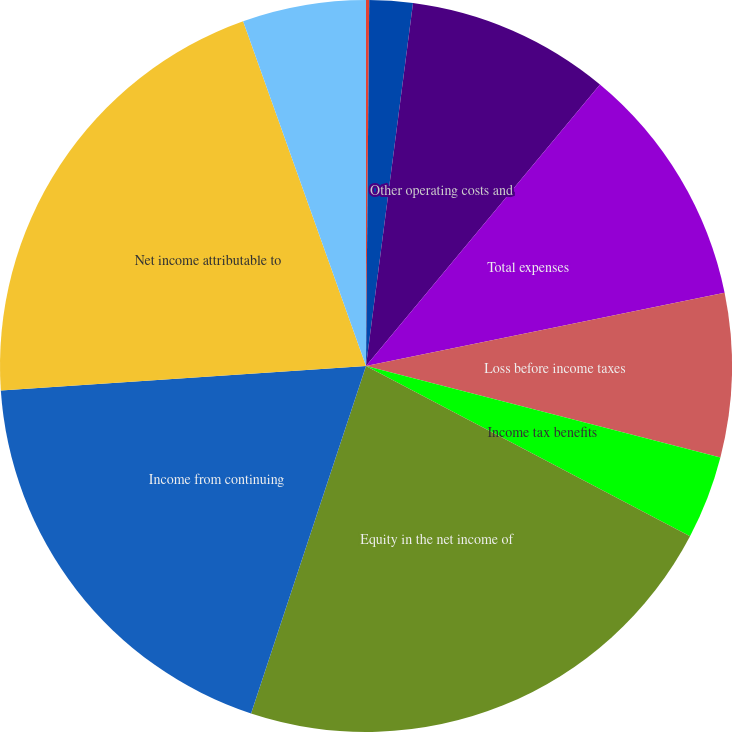<chart> <loc_0><loc_0><loc_500><loc_500><pie_chart><fcel>Net investment income (loss)<fcel>Total revenues<fcel>Other operating costs and<fcel>Total expenses<fcel>Loss before income taxes<fcel>Income tax benefits<fcel>Equity in the net income of<fcel>Income from continuing<fcel>Net income attributable to<fcel>Preferred stock dividends<nl><fcel>0.14%<fcel>1.91%<fcel>8.99%<fcel>10.76%<fcel>7.22%<fcel>3.68%<fcel>22.39%<fcel>18.85%<fcel>20.62%<fcel>5.45%<nl></chart> 